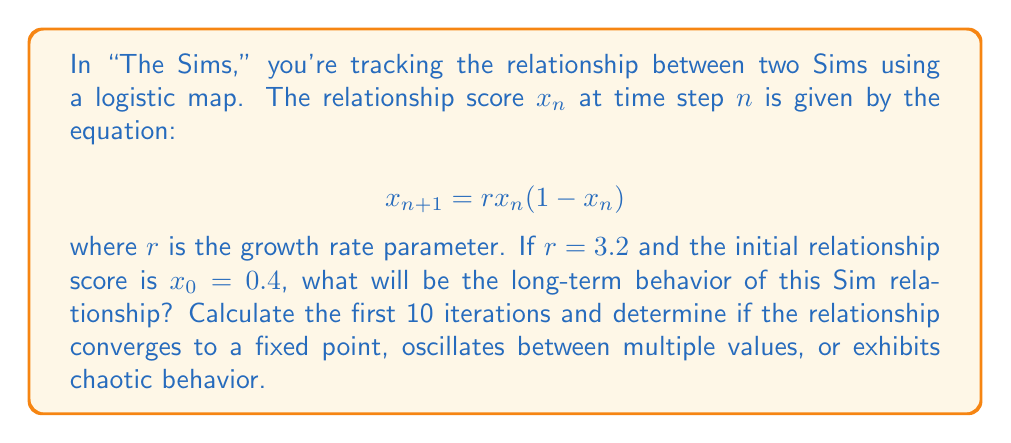Can you answer this question? Let's approach this step-by-step:

1) We're given the logistic map equation: $x_{n+1} = rx_n(1-x_n)$
   With $r = 3.2$ and $x_0 = 0.4$

2) Let's calculate the first 10 iterations:

   $x_1 = 3.2 * 0.4 * (1-0.4) = 0.768$
   $x_2 = 3.2 * 0.768 * (1-0.768) ≈ 0.570$
   $x_3 ≈ 0.784$
   $x_4 ≈ 0.541$
   $x_5 ≈ 0.794$
   $x_6 ≈ 0.523$
   $x_7 ≈ 0.798$
   $x_8 ≈ 0.516$
   $x_9 ≈ 0.799$
   $x_{10} ≈ 0.513$

3) Observing these values, we can see that the relationship score doesn't converge to a single fixed point.

4) Instead, it appears to be oscillating between two values: approximately 0.8 and 0.5.

5) This behavior is characteristic of a period-2 cycle in the logistic map.

6) For the logistic map, we know that:
   - For $1 < r < 3$, it converges to a fixed point.
   - For $3 < r < 1+\sqrt{6} ≈ 3.45$, it oscillates between two values.
   - For $r > 3.57$, it exhibits chaotic behavior.

7) Since $r = 3.2$ falls in the second range, this confirms our observation of a period-2 cycle.

Therefore, the long-term behavior of this Sim relationship will be an oscillation between two values, representing alternating periods of better and worse relationship scores.
Answer: Period-2 oscillation 